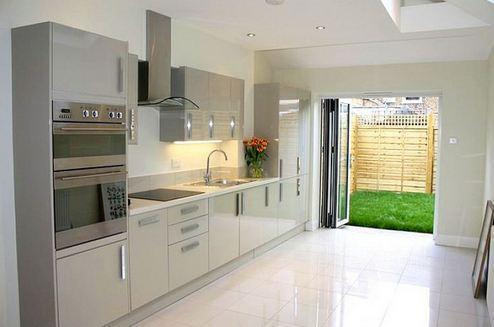What is the green object on top of the counter to the right of the sink?
Select the accurate response from the four choices given to answer the question.
Options: Fern, flowers, grass, tree. Flowers. 